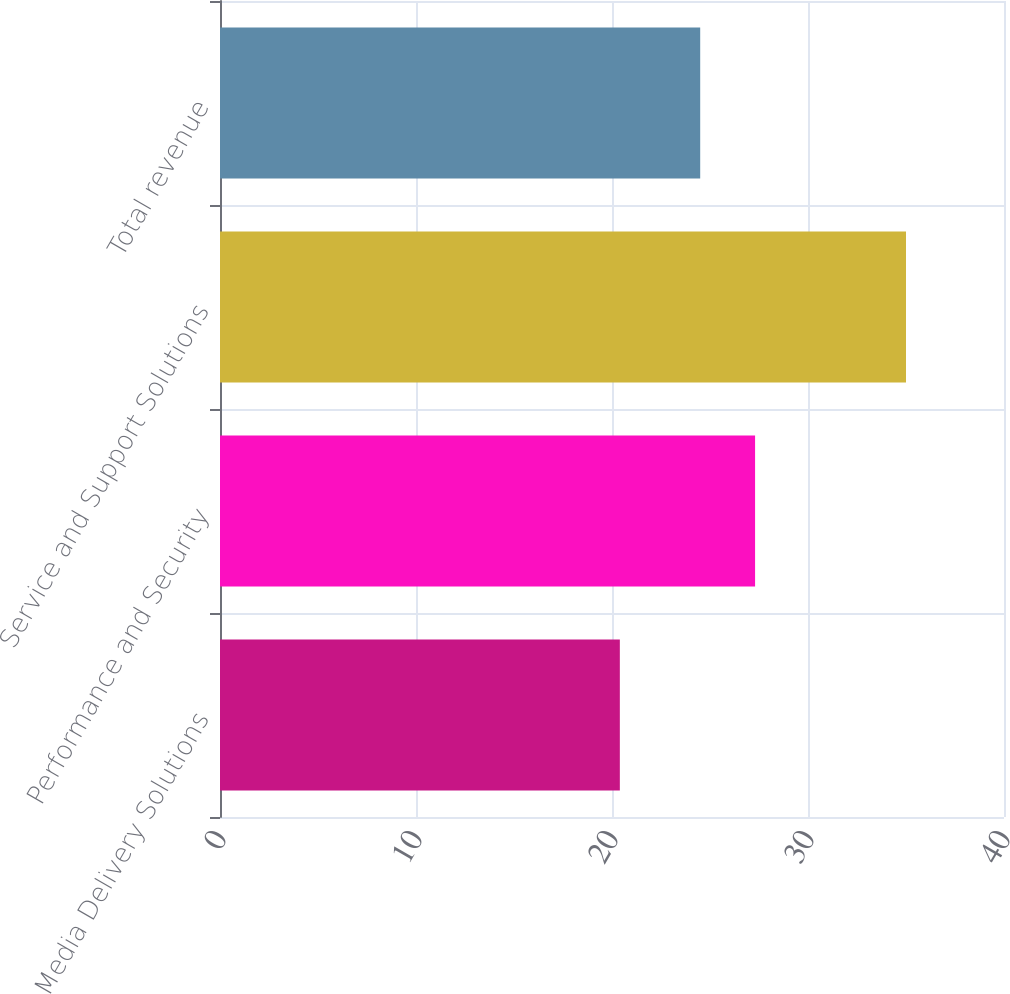<chart> <loc_0><loc_0><loc_500><loc_500><bar_chart><fcel>Media Delivery Solutions<fcel>Performance and Security<fcel>Service and Support Solutions<fcel>Total revenue<nl><fcel>20.4<fcel>27.3<fcel>35<fcel>24.5<nl></chart> 